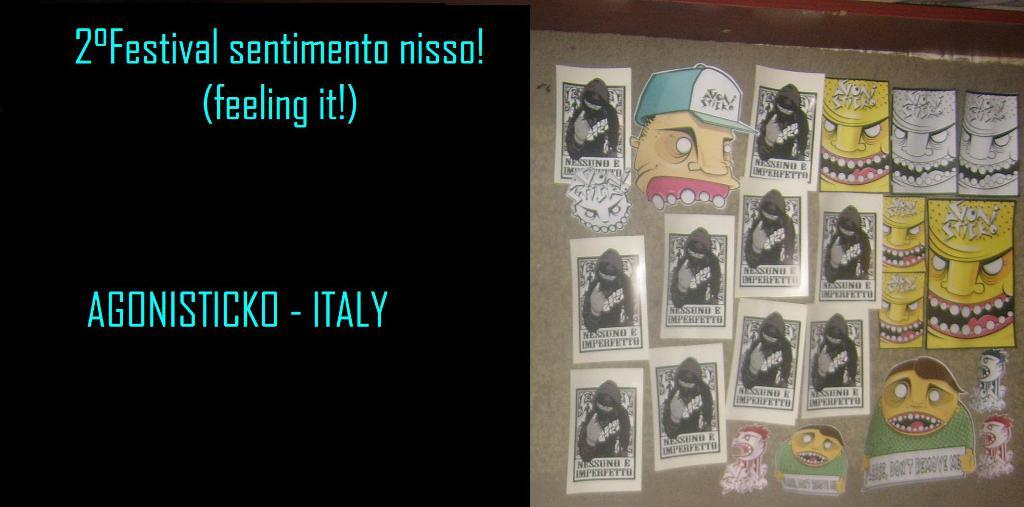Provide a one-sentence caption for the provided image. Board that has pictures of cartoon faces on it and the country ITALY on the left. 